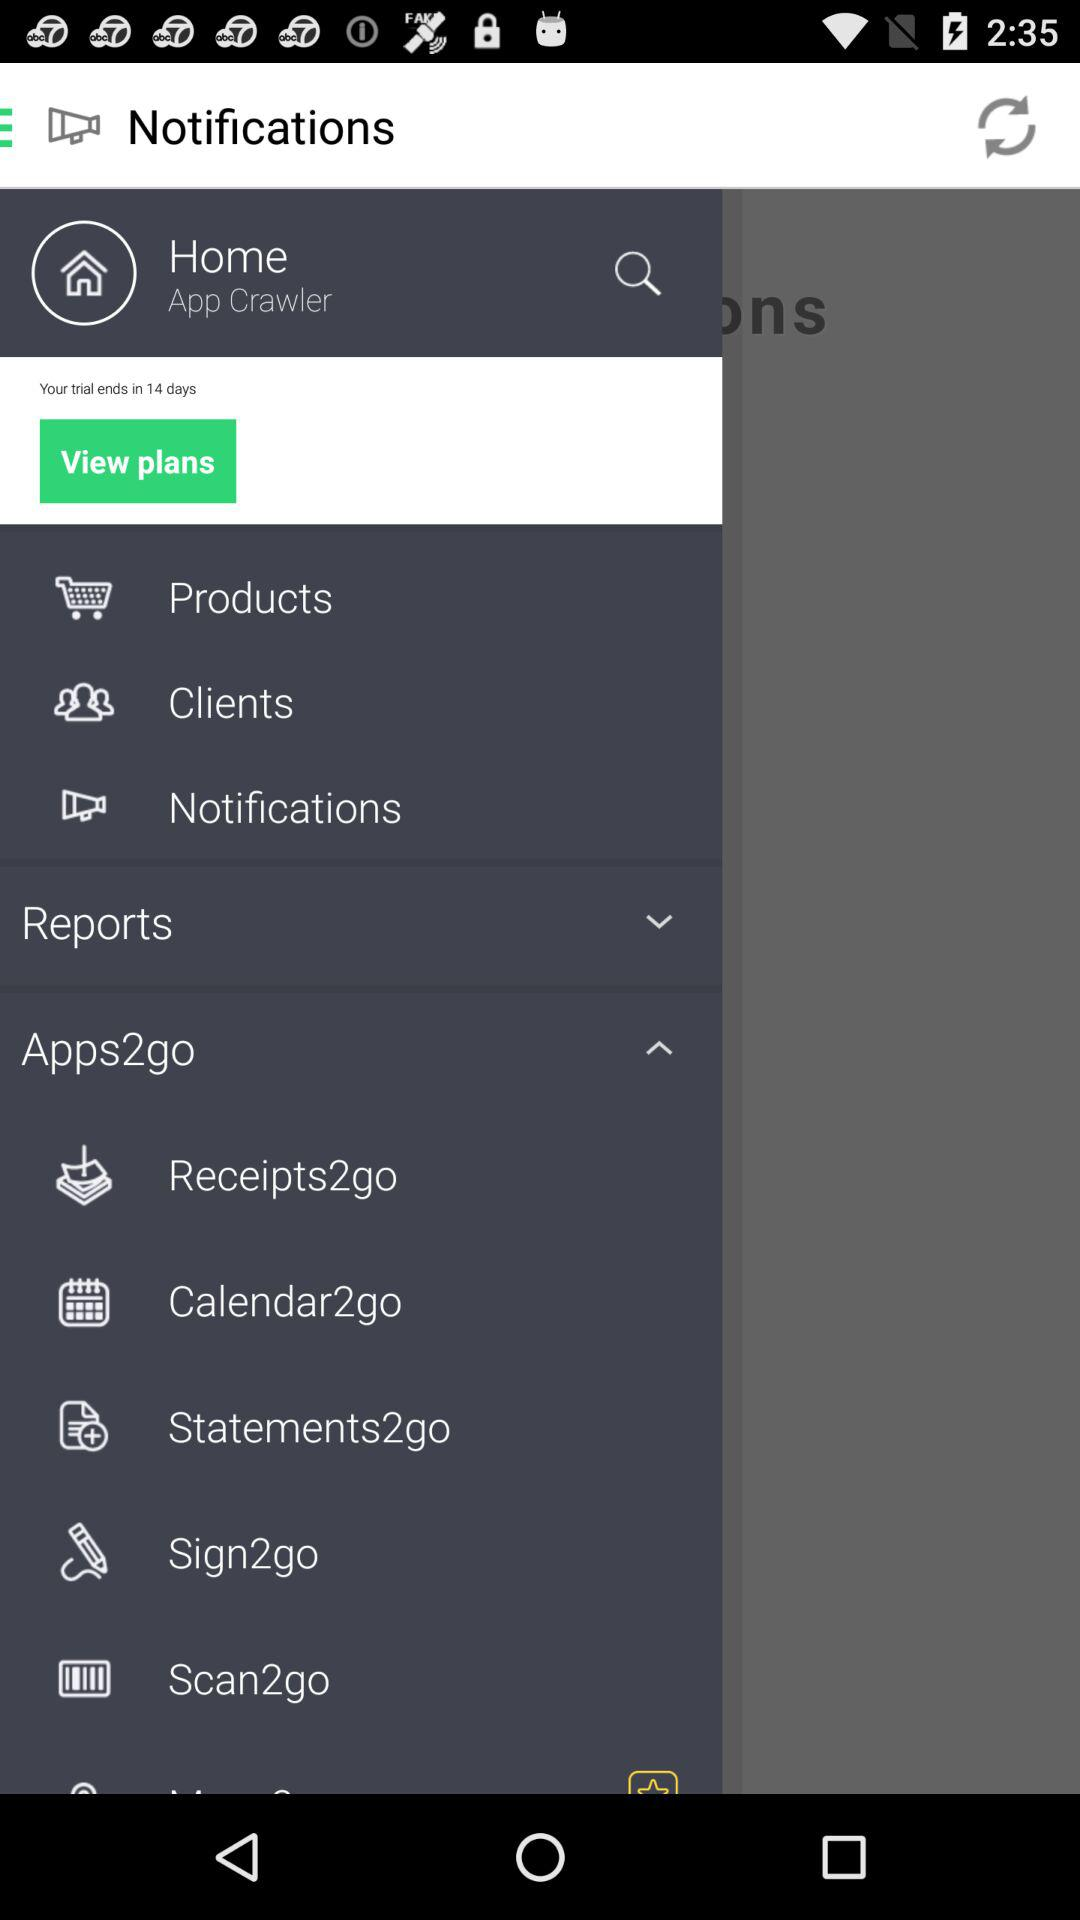When will the trial period end? The trial period will end in 14 days. 